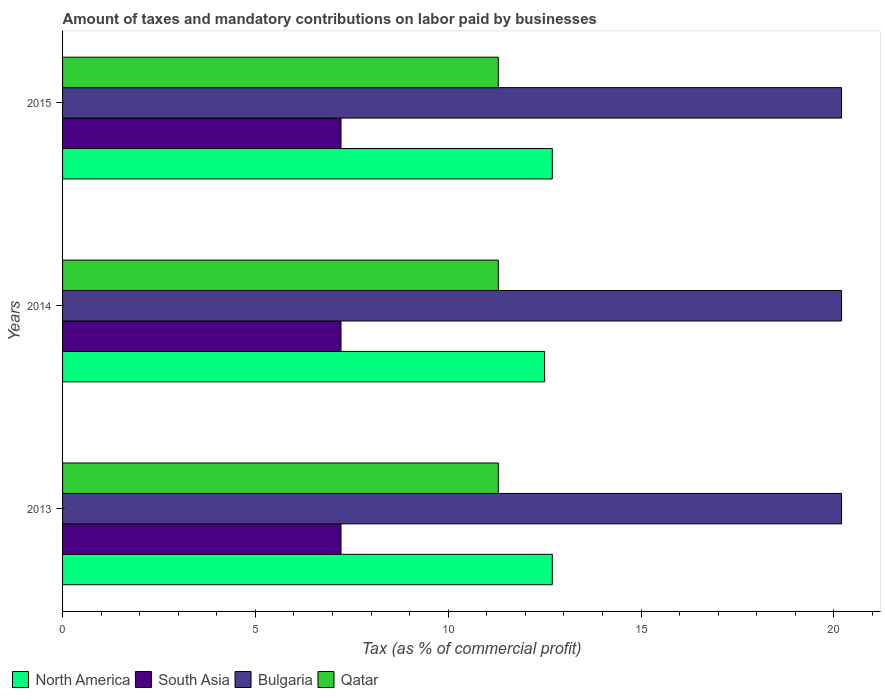How many different coloured bars are there?
Your response must be concise. 4. How many bars are there on the 3rd tick from the top?
Offer a terse response. 4. What is the label of the 3rd group of bars from the top?
Make the answer very short. 2013. In how many cases, is the number of bars for a given year not equal to the number of legend labels?
Provide a succinct answer. 0. What is the percentage of taxes paid by businesses in North America in 2015?
Provide a succinct answer. 12.7. Across all years, what is the maximum percentage of taxes paid by businesses in South Asia?
Offer a very short reply. 7.22. In which year was the percentage of taxes paid by businesses in Qatar maximum?
Your response must be concise. 2013. What is the total percentage of taxes paid by businesses in North America in the graph?
Offer a very short reply. 37.9. What is the difference between the percentage of taxes paid by businesses in South Asia in 2013 and that in 2015?
Offer a terse response. 0. What is the difference between the percentage of taxes paid by businesses in Qatar in 2014 and the percentage of taxes paid by businesses in North America in 2013?
Make the answer very short. -1.4. What is the average percentage of taxes paid by businesses in South Asia per year?
Offer a terse response. 7.22. In the year 2015, what is the difference between the percentage of taxes paid by businesses in North America and percentage of taxes paid by businesses in South Asia?
Offer a very short reply. 5.48. What is the ratio of the percentage of taxes paid by businesses in Qatar in 2013 to that in 2015?
Offer a terse response. 1. Is the percentage of taxes paid by businesses in North America in 2013 less than that in 2014?
Give a very brief answer. No. Is the difference between the percentage of taxes paid by businesses in North America in 2013 and 2014 greater than the difference between the percentage of taxes paid by businesses in South Asia in 2013 and 2014?
Your response must be concise. Yes. What is the difference between the highest and the second highest percentage of taxes paid by businesses in Bulgaria?
Make the answer very short. 0. What is the difference between the highest and the lowest percentage of taxes paid by businesses in North America?
Provide a succinct answer. 0.2. Is the sum of the percentage of taxes paid by businesses in North America in 2014 and 2015 greater than the maximum percentage of taxes paid by businesses in Bulgaria across all years?
Offer a terse response. Yes. What does the 4th bar from the bottom in 2013 represents?
Provide a short and direct response. Qatar. How many bars are there?
Your answer should be very brief. 12. Are all the bars in the graph horizontal?
Your answer should be compact. Yes. Are the values on the major ticks of X-axis written in scientific E-notation?
Your answer should be very brief. No. Does the graph contain grids?
Make the answer very short. No. Where does the legend appear in the graph?
Give a very brief answer. Bottom left. What is the title of the graph?
Keep it short and to the point. Amount of taxes and mandatory contributions on labor paid by businesses. What is the label or title of the X-axis?
Your answer should be compact. Tax (as % of commercial profit). What is the label or title of the Y-axis?
Your answer should be compact. Years. What is the Tax (as % of commercial profit) of South Asia in 2013?
Your answer should be compact. 7.22. What is the Tax (as % of commercial profit) of Bulgaria in 2013?
Ensure brevity in your answer.  20.2. What is the Tax (as % of commercial profit) of South Asia in 2014?
Your answer should be very brief. 7.22. What is the Tax (as % of commercial profit) of Bulgaria in 2014?
Provide a short and direct response. 20.2. What is the Tax (as % of commercial profit) in North America in 2015?
Your response must be concise. 12.7. What is the Tax (as % of commercial profit) in South Asia in 2015?
Make the answer very short. 7.22. What is the Tax (as % of commercial profit) in Bulgaria in 2015?
Give a very brief answer. 20.2. What is the Tax (as % of commercial profit) of Qatar in 2015?
Provide a succinct answer. 11.3. Across all years, what is the maximum Tax (as % of commercial profit) of South Asia?
Keep it short and to the point. 7.22. Across all years, what is the maximum Tax (as % of commercial profit) of Bulgaria?
Ensure brevity in your answer.  20.2. Across all years, what is the maximum Tax (as % of commercial profit) in Qatar?
Offer a very short reply. 11.3. Across all years, what is the minimum Tax (as % of commercial profit) in South Asia?
Make the answer very short. 7.22. Across all years, what is the minimum Tax (as % of commercial profit) of Bulgaria?
Offer a terse response. 20.2. What is the total Tax (as % of commercial profit) in North America in the graph?
Provide a succinct answer. 37.9. What is the total Tax (as % of commercial profit) in South Asia in the graph?
Your answer should be compact. 21.66. What is the total Tax (as % of commercial profit) of Bulgaria in the graph?
Ensure brevity in your answer.  60.6. What is the total Tax (as % of commercial profit) in Qatar in the graph?
Provide a short and direct response. 33.9. What is the difference between the Tax (as % of commercial profit) in Bulgaria in 2013 and that in 2014?
Ensure brevity in your answer.  0. What is the difference between the Tax (as % of commercial profit) in North America in 2013 and that in 2015?
Provide a succinct answer. 0. What is the difference between the Tax (as % of commercial profit) of Bulgaria in 2013 and that in 2015?
Your answer should be compact. 0. What is the difference between the Tax (as % of commercial profit) in Qatar in 2013 and that in 2015?
Provide a succinct answer. 0. What is the difference between the Tax (as % of commercial profit) of South Asia in 2014 and that in 2015?
Offer a very short reply. 0. What is the difference between the Tax (as % of commercial profit) of North America in 2013 and the Tax (as % of commercial profit) of South Asia in 2014?
Offer a terse response. 5.48. What is the difference between the Tax (as % of commercial profit) of North America in 2013 and the Tax (as % of commercial profit) of Bulgaria in 2014?
Your answer should be very brief. -7.5. What is the difference between the Tax (as % of commercial profit) of South Asia in 2013 and the Tax (as % of commercial profit) of Bulgaria in 2014?
Provide a succinct answer. -12.98. What is the difference between the Tax (as % of commercial profit) of South Asia in 2013 and the Tax (as % of commercial profit) of Qatar in 2014?
Your answer should be very brief. -4.08. What is the difference between the Tax (as % of commercial profit) in North America in 2013 and the Tax (as % of commercial profit) in South Asia in 2015?
Keep it short and to the point. 5.48. What is the difference between the Tax (as % of commercial profit) of South Asia in 2013 and the Tax (as % of commercial profit) of Bulgaria in 2015?
Offer a very short reply. -12.98. What is the difference between the Tax (as % of commercial profit) in South Asia in 2013 and the Tax (as % of commercial profit) in Qatar in 2015?
Keep it short and to the point. -4.08. What is the difference between the Tax (as % of commercial profit) in Bulgaria in 2013 and the Tax (as % of commercial profit) in Qatar in 2015?
Make the answer very short. 8.9. What is the difference between the Tax (as % of commercial profit) in North America in 2014 and the Tax (as % of commercial profit) in South Asia in 2015?
Give a very brief answer. 5.28. What is the difference between the Tax (as % of commercial profit) of South Asia in 2014 and the Tax (as % of commercial profit) of Bulgaria in 2015?
Provide a short and direct response. -12.98. What is the difference between the Tax (as % of commercial profit) in South Asia in 2014 and the Tax (as % of commercial profit) in Qatar in 2015?
Give a very brief answer. -4.08. What is the difference between the Tax (as % of commercial profit) in Bulgaria in 2014 and the Tax (as % of commercial profit) in Qatar in 2015?
Your answer should be compact. 8.9. What is the average Tax (as % of commercial profit) of North America per year?
Your answer should be compact. 12.63. What is the average Tax (as % of commercial profit) in South Asia per year?
Your answer should be compact. 7.22. What is the average Tax (as % of commercial profit) of Bulgaria per year?
Make the answer very short. 20.2. What is the average Tax (as % of commercial profit) in Qatar per year?
Make the answer very short. 11.3. In the year 2013, what is the difference between the Tax (as % of commercial profit) of North America and Tax (as % of commercial profit) of South Asia?
Your response must be concise. 5.48. In the year 2013, what is the difference between the Tax (as % of commercial profit) of North America and Tax (as % of commercial profit) of Bulgaria?
Ensure brevity in your answer.  -7.5. In the year 2013, what is the difference between the Tax (as % of commercial profit) in South Asia and Tax (as % of commercial profit) in Bulgaria?
Offer a very short reply. -12.98. In the year 2013, what is the difference between the Tax (as % of commercial profit) in South Asia and Tax (as % of commercial profit) in Qatar?
Your response must be concise. -4.08. In the year 2014, what is the difference between the Tax (as % of commercial profit) in North America and Tax (as % of commercial profit) in South Asia?
Give a very brief answer. 5.28. In the year 2014, what is the difference between the Tax (as % of commercial profit) in South Asia and Tax (as % of commercial profit) in Bulgaria?
Ensure brevity in your answer.  -12.98. In the year 2014, what is the difference between the Tax (as % of commercial profit) in South Asia and Tax (as % of commercial profit) in Qatar?
Provide a short and direct response. -4.08. In the year 2014, what is the difference between the Tax (as % of commercial profit) in Bulgaria and Tax (as % of commercial profit) in Qatar?
Give a very brief answer. 8.9. In the year 2015, what is the difference between the Tax (as % of commercial profit) in North America and Tax (as % of commercial profit) in South Asia?
Provide a short and direct response. 5.48. In the year 2015, what is the difference between the Tax (as % of commercial profit) of North America and Tax (as % of commercial profit) of Qatar?
Provide a short and direct response. 1.4. In the year 2015, what is the difference between the Tax (as % of commercial profit) of South Asia and Tax (as % of commercial profit) of Bulgaria?
Ensure brevity in your answer.  -12.98. In the year 2015, what is the difference between the Tax (as % of commercial profit) in South Asia and Tax (as % of commercial profit) in Qatar?
Make the answer very short. -4.08. In the year 2015, what is the difference between the Tax (as % of commercial profit) in Bulgaria and Tax (as % of commercial profit) in Qatar?
Provide a short and direct response. 8.9. What is the ratio of the Tax (as % of commercial profit) of Bulgaria in 2013 to that in 2014?
Offer a very short reply. 1. What is the ratio of the Tax (as % of commercial profit) in North America in 2013 to that in 2015?
Give a very brief answer. 1. What is the ratio of the Tax (as % of commercial profit) of South Asia in 2013 to that in 2015?
Provide a succinct answer. 1. What is the ratio of the Tax (as % of commercial profit) in Bulgaria in 2013 to that in 2015?
Offer a terse response. 1. What is the ratio of the Tax (as % of commercial profit) of Qatar in 2013 to that in 2015?
Ensure brevity in your answer.  1. What is the ratio of the Tax (as % of commercial profit) of North America in 2014 to that in 2015?
Your answer should be very brief. 0.98. What is the ratio of the Tax (as % of commercial profit) in Qatar in 2014 to that in 2015?
Ensure brevity in your answer.  1. What is the difference between the highest and the second highest Tax (as % of commercial profit) in North America?
Make the answer very short. 0. What is the difference between the highest and the second highest Tax (as % of commercial profit) in Qatar?
Offer a very short reply. 0. What is the difference between the highest and the lowest Tax (as % of commercial profit) of North America?
Keep it short and to the point. 0.2. What is the difference between the highest and the lowest Tax (as % of commercial profit) of South Asia?
Offer a terse response. 0. What is the difference between the highest and the lowest Tax (as % of commercial profit) of Bulgaria?
Your answer should be very brief. 0. What is the difference between the highest and the lowest Tax (as % of commercial profit) in Qatar?
Make the answer very short. 0. 